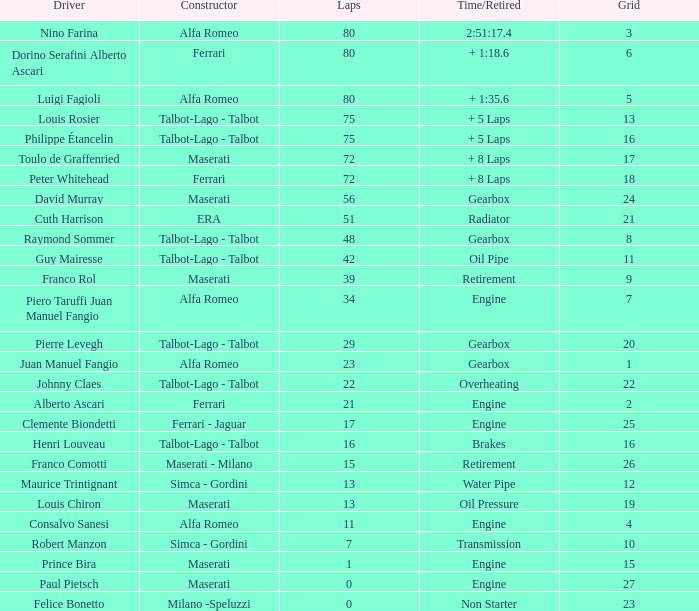When juan manuel fangio drives and the number of laps is below 39, what is the highest grid he can reach? 1.0. 